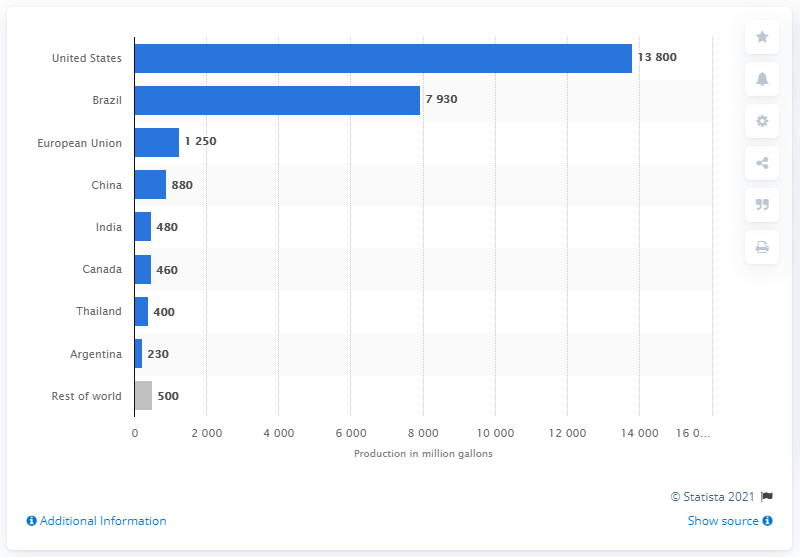Mention a couple of crucial points in this snapshot. In 2020, the United States produced a total of 138,000 gallons of fuel ethanol. Brazil was the country that produced the most fuel ethanol in the world in 2020. 